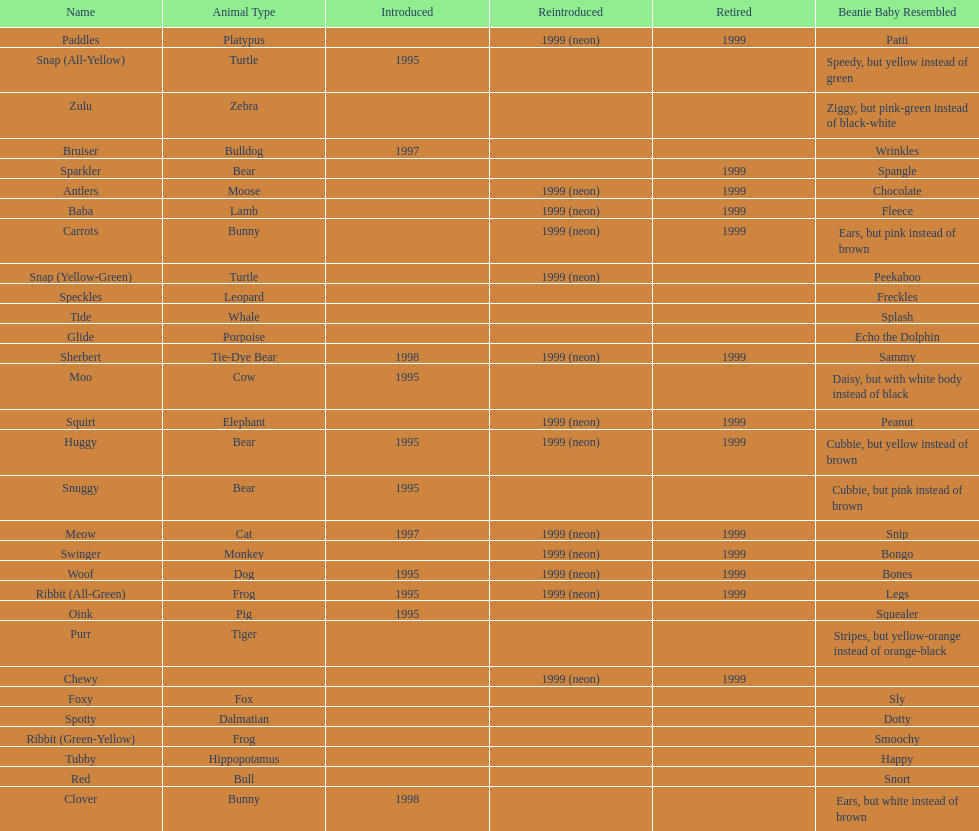What is the number of frog pillow pals? 2. 